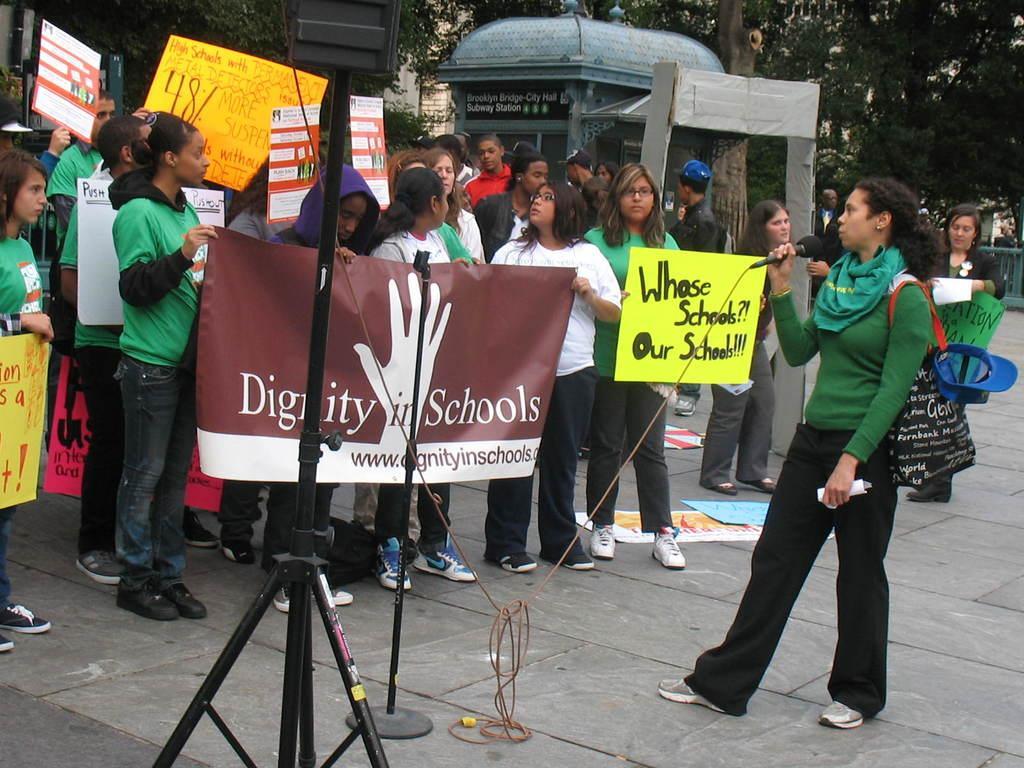Can you describe this image briefly? In this image I can see group of people standing, the person in front wearing green shirt, black pant and holding a microphone. Background I can see few banners in brown, yellow and red color and I can see trees in green color. 